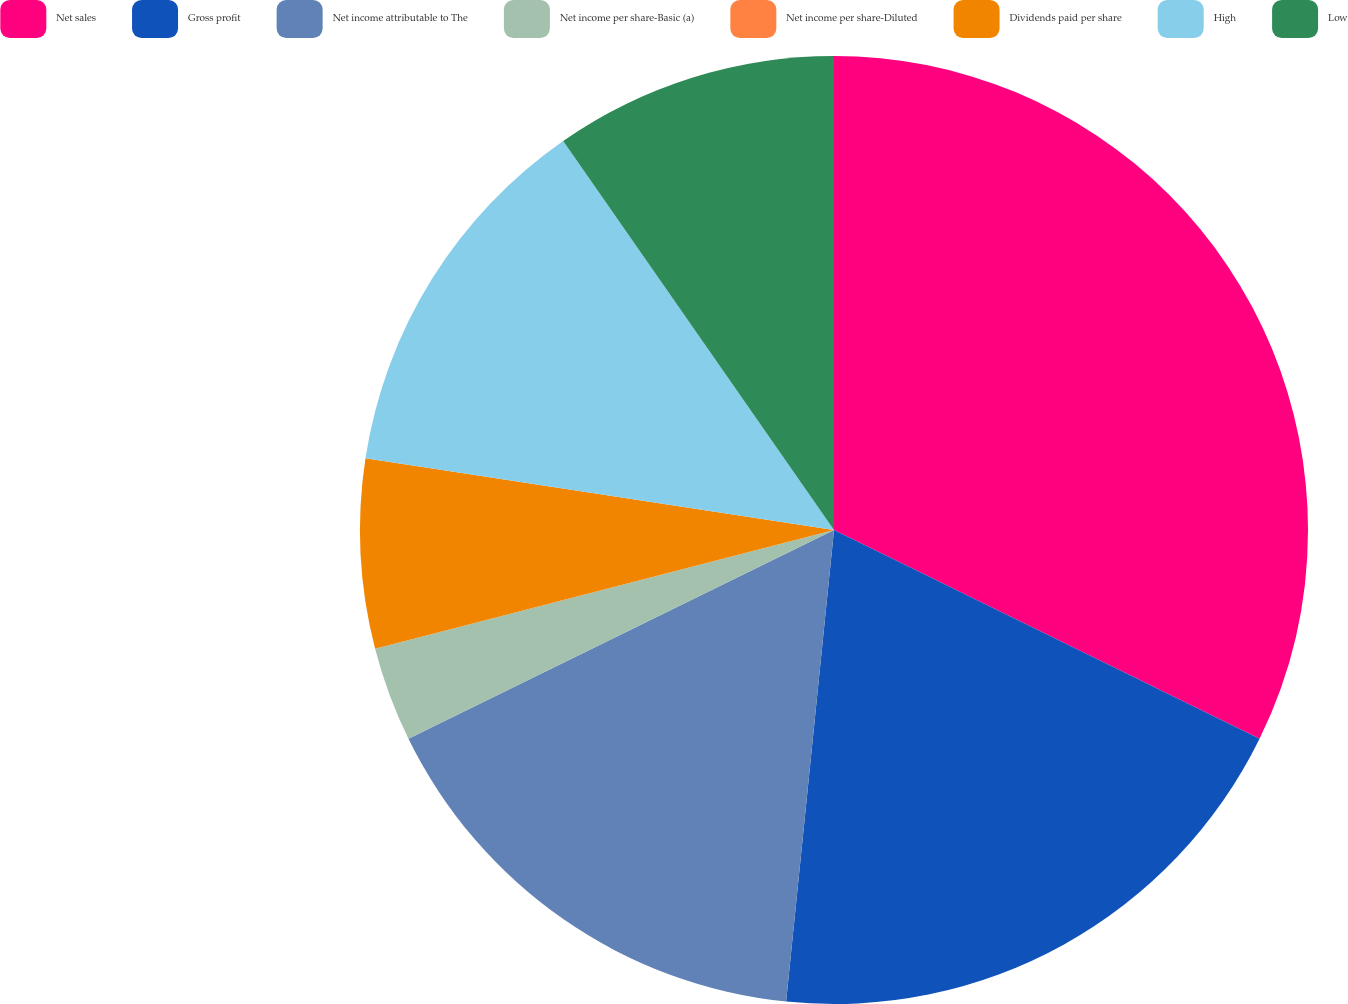Convert chart to OTSL. <chart><loc_0><loc_0><loc_500><loc_500><pie_chart><fcel>Net sales<fcel>Gross profit<fcel>Net income attributable to The<fcel>Net income per share-Basic (a)<fcel>Net income per share-Diluted<fcel>Dividends paid per share<fcel>High<fcel>Low<nl><fcel>32.26%<fcel>19.35%<fcel>16.13%<fcel>3.23%<fcel>0.0%<fcel>6.45%<fcel>12.9%<fcel>9.68%<nl></chart> 